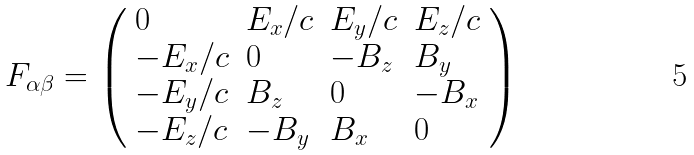Convert formula to latex. <formula><loc_0><loc_0><loc_500><loc_500>F _ { \alpha \beta } = \left ( { \begin{array} { l l l l } { 0 } & { E _ { x } / c } & { E _ { y } / c } & { E _ { z } / c } \\ { - E _ { x } / c } & { 0 } & { - B _ { z } } & { B _ { y } } \\ { - E _ { y } / c } & { B _ { z } } & { 0 } & { - B _ { x } } \\ { - E _ { z } / c } & { - B _ { y } } & { B _ { x } } & { 0 } \end{array} } \right )</formula> 